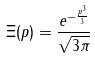Convert formula to latex. <formula><loc_0><loc_0><loc_500><loc_500>\Xi ( p ) = \frac { e ^ { - \frac { p ^ { 3 } } { 3 } } } { \sqrt { 3 \pi } }</formula> 